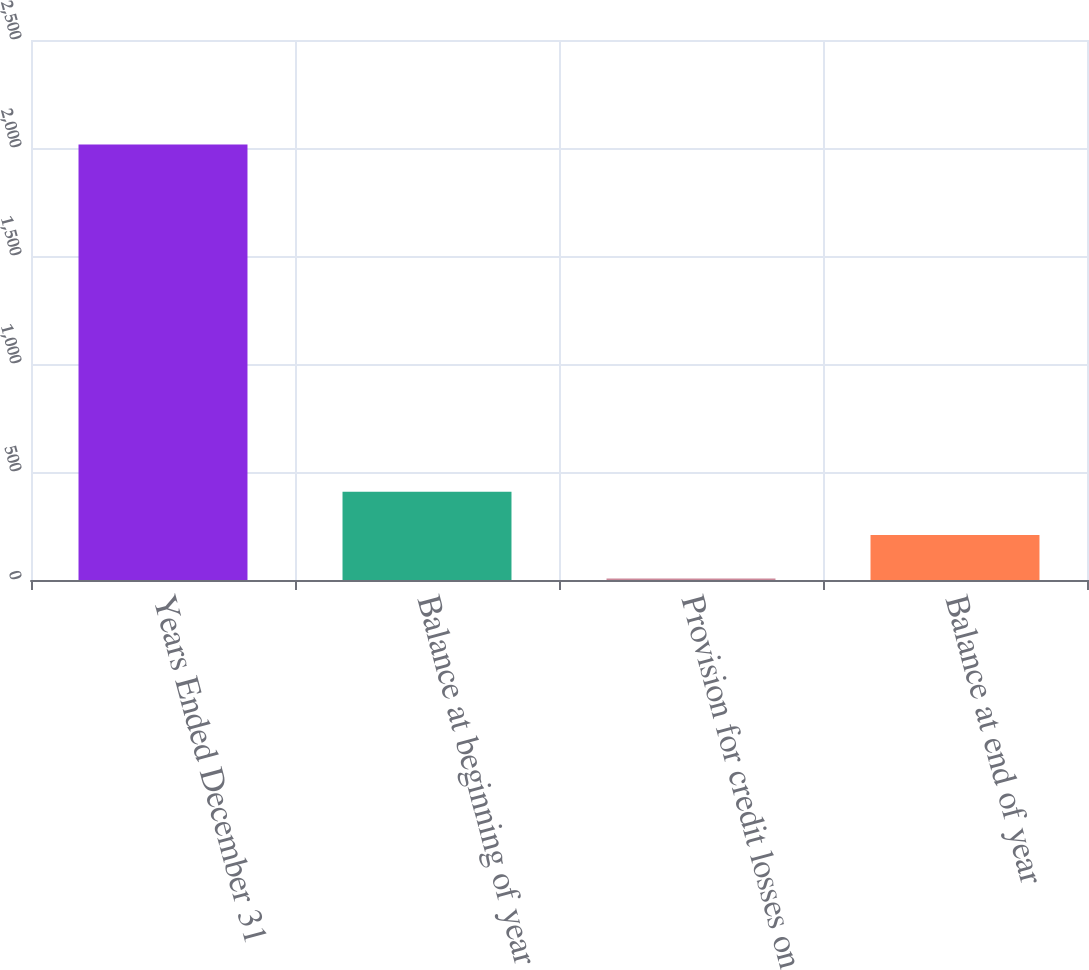<chart> <loc_0><loc_0><loc_500><loc_500><bar_chart><fcel>Years Ended December 31<fcel>Balance at beginning of year<fcel>Provision for credit losses on<fcel>Balance at end of year<nl><fcel>2016<fcel>408.8<fcel>7<fcel>207.9<nl></chart> 